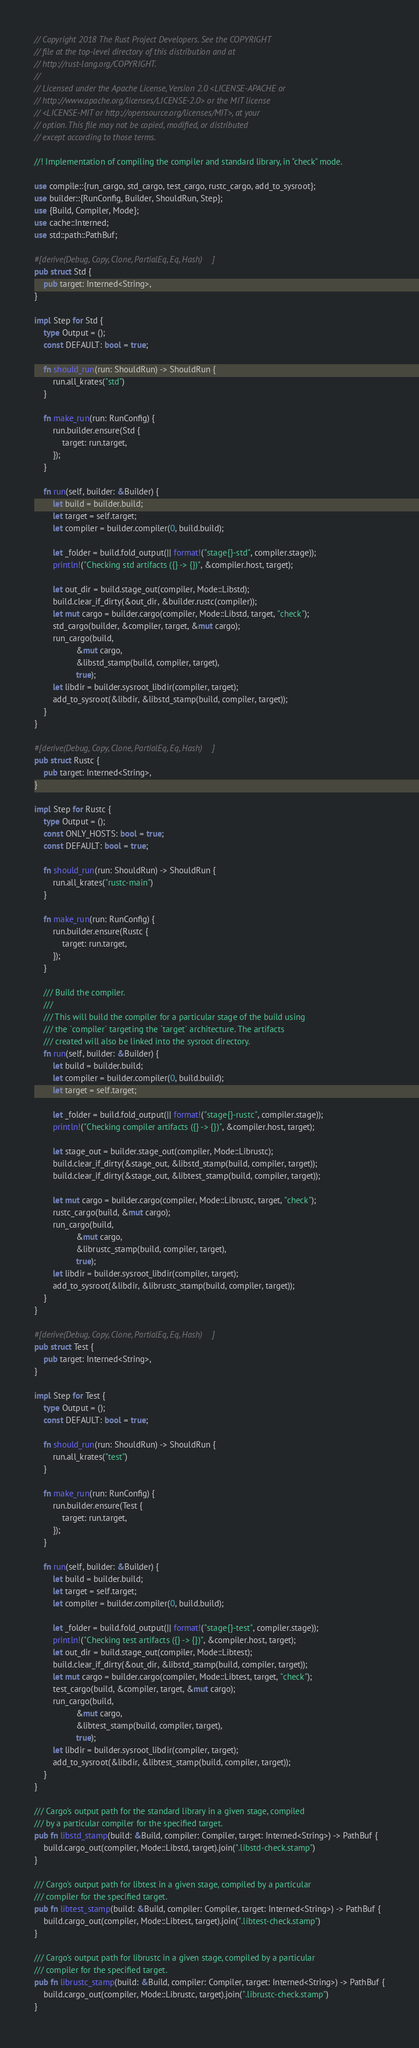<code> <loc_0><loc_0><loc_500><loc_500><_Rust_>// Copyright 2018 The Rust Project Developers. See the COPYRIGHT
// file at the top-level directory of this distribution and at
// http://rust-lang.org/COPYRIGHT.
//
// Licensed under the Apache License, Version 2.0 <LICENSE-APACHE or
// http://www.apache.org/licenses/LICENSE-2.0> or the MIT license
// <LICENSE-MIT or http://opensource.org/licenses/MIT>, at your
// option. This file may not be copied, modified, or distributed
// except according to those terms.

//! Implementation of compiling the compiler and standard library, in "check" mode.

use compile::{run_cargo, std_cargo, test_cargo, rustc_cargo, add_to_sysroot};
use builder::{RunConfig, Builder, ShouldRun, Step};
use {Build, Compiler, Mode};
use cache::Interned;
use std::path::PathBuf;

#[derive(Debug, Copy, Clone, PartialEq, Eq, Hash)]
pub struct Std {
    pub target: Interned<String>,
}

impl Step for Std {
    type Output = ();
    const DEFAULT: bool = true;

    fn should_run(run: ShouldRun) -> ShouldRun {
        run.all_krates("std")
    }

    fn make_run(run: RunConfig) {
        run.builder.ensure(Std {
            target: run.target,
        });
    }

    fn run(self, builder: &Builder) {
        let build = builder.build;
        let target = self.target;
        let compiler = builder.compiler(0, build.build);

        let _folder = build.fold_output(|| format!("stage{}-std", compiler.stage));
        println!("Checking std artifacts ({} -> {})", &compiler.host, target);

        let out_dir = build.stage_out(compiler, Mode::Libstd);
        build.clear_if_dirty(&out_dir, &builder.rustc(compiler));
        let mut cargo = builder.cargo(compiler, Mode::Libstd, target, "check");
        std_cargo(builder, &compiler, target, &mut cargo);
        run_cargo(build,
                  &mut cargo,
                  &libstd_stamp(build, compiler, target),
                  true);
        let libdir = builder.sysroot_libdir(compiler, target);
        add_to_sysroot(&libdir, &libstd_stamp(build, compiler, target));
    }
}

#[derive(Debug, Copy, Clone, PartialEq, Eq, Hash)]
pub struct Rustc {
    pub target: Interned<String>,
}

impl Step for Rustc {
    type Output = ();
    const ONLY_HOSTS: bool = true;
    const DEFAULT: bool = true;

    fn should_run(run: ShouldRun) -> ShouldRun {
        run.all_krates("rustc-main")
    }

    fn make_run(run: RunConfig) {
        run.builder.ensure(Rustc {
            target: run.target,
        });
    }

    /// Build the compiler.
    ///
    /// This will build the compiler for a particular stage of the build using
    /// the `compiler` targeting the `target` architecture. The artifacts
    /// created will also be linked into the sysroot directory.
    fn run(self, builder: &Builder) {
        let build = builder.build;
        let compiler = builder.compiler(0, build.build);
        let target = self.target;

        let _folder = build.fold_output(|| format!("stage{}-rustc", compiler.stage));
        println!("Checking compiler artifacts ({} -> {})", &compiler.host, target);

        let stage_out = builder.stage_out(compiler, Mode::Librustc);
        build.clear_if_dirty(&stage_out, &libstd_stamp(build, compiler, target));
        build.clear_if_dirty(&stage_out, &libtest_stamp(build, compiler, target));

        let mut cargo = builder.cargo(compiler, Mode::Librustc, target, "check");
        rustc_cargo(build, &mut cargo);
        run_cargo(build,
                  &mut cargo,
                  &librustc_stamp(build, compiler, target),
                  true);
        let libdir = builder.sysroot_libdir(compiler, target);
        add_to_sysroot(&libdir, &librustc_stamp(build, compiler, target));
    }
}

#[derive(Debug, Copy, Clone, PartialEq, Eq, Hash)]
pub struct Test {
    pub target: Interned<String>,
}

impl Step for Test {
    type Output = ();
    const DEFAULT: bool = true;

    fn should_run(run: ShouldRun) -> ShouldRun {
        run.all_krates("test")
    }

    fn make_run(run: RunConfig) {
        run.builder.ensure(Test {
            target: run.target,
        });
    }

    fn run(self, builder: &Builder) {
        let build = builder.build;
        let target = self.target;
        let compiler = builder.compiler(0, build.build);

        let _folder = build.fold_output(|| format!("stage{}-test", compiler.stage));
        println!("Checking test artifacts ({} -> {})", &compiler.host, target);
        let out_dir = build.stage_out(compiler, Mode::Libtest);
        build.clear_if_dirty(&out_dir, &libstd_stamp(build, compiler, target));
        let mut cargo = builder.cargo(compiler, Mode::Libtest, target, "check");
        test_cargo(build, &compiler, target, &mut cargo);
        run_cargo(build,
                  &mut cargo,
                  &libtest_stamp(build, compiler, target),
                  true);
        let libdir = builder.sysroot_libdir(compiler, target);
        add_to_sysroot(&libdir, &libtest_stamp(build, compiler, target));
    }
}

/// Cargo's output path for the standard library in a given stage, compiled
/// by a particular compiler for the specified target.
pub fn libstd_stamp(build: &Build, compiler: Compiler, target: Interned<String>) -> PathBuf {
    build.cargo_out(compiler, Mode::Libstd, target).join(".libstd-check.stamp")
}

/// Cargo's output path for libtest in a given stage, compiled by a particular
/// compiler for the specified target.
pub fn libtest_stamp(build: &Build, compiler: Compiler, target: Interned<String>) -> PathBuf {
    build.cargo_out(compiler, Mode::Libtest, target).join(".libtest-check.stamp")
}

/// Cargo's output path for librustc in a given stage, compiled by a particular
/// compiler for the specified target.
pub fn librustc_stamp(build: &Build, compiler: Compiler, target: Interned<String>) -> PathBuf {
    build.cargo_out(compiler, Mode::Librustc, target).join(".librustc-check.stamp")
}
</code> 